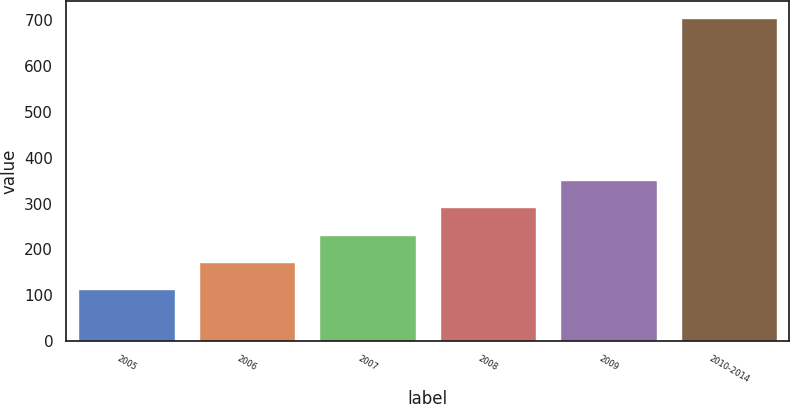Convert chart to OTSL. <chart><loc_0><loc_0><loc_500><loc_500><bar_chart><fcel>2005<fcel>2006<fcel>2007<fcel>2008<fcel>2009<fcel>2010-2014<nl><fcel>114<fcel>173.2<fcel>232.4<fcel>291.6<fcel>350.8<fcel>706<nl></chart> 